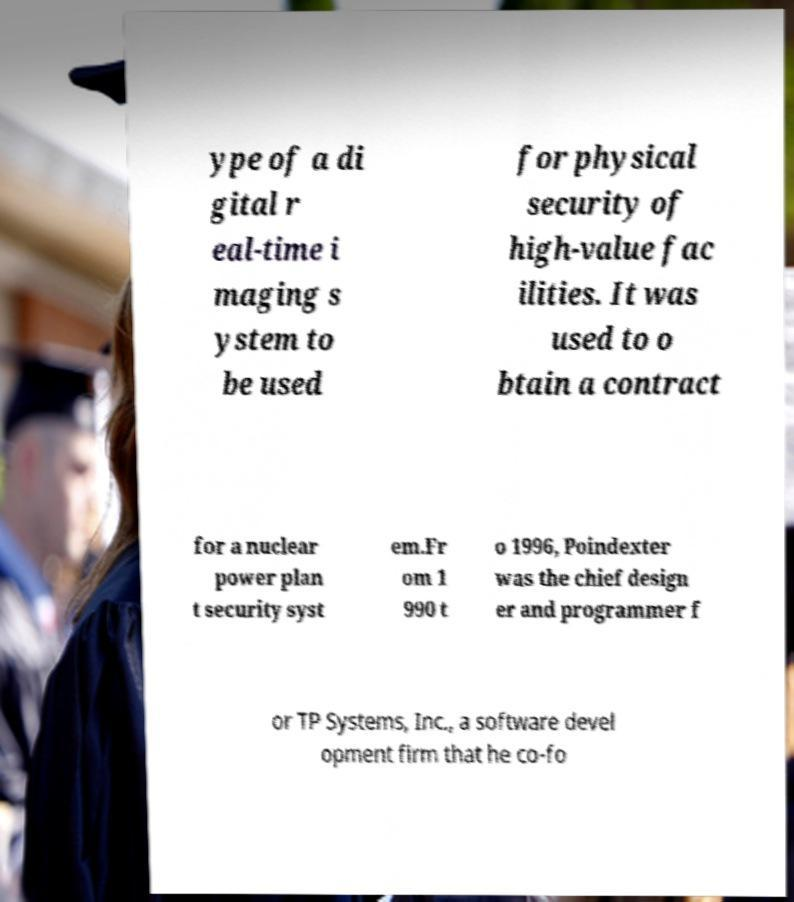Can you accurately transcribe the text from the provided image for me? ype of a di gital r eal-time i maging s ystem to be used for physical security of high-value fac ilities. It was used to o btain a contract for a nuclear power plan t security syst em.Fr om 1 990 t o 1996, Poindexter was the chief design er and programmer f or TP Systems, Inc., a software devel opment firm that he co-fo 